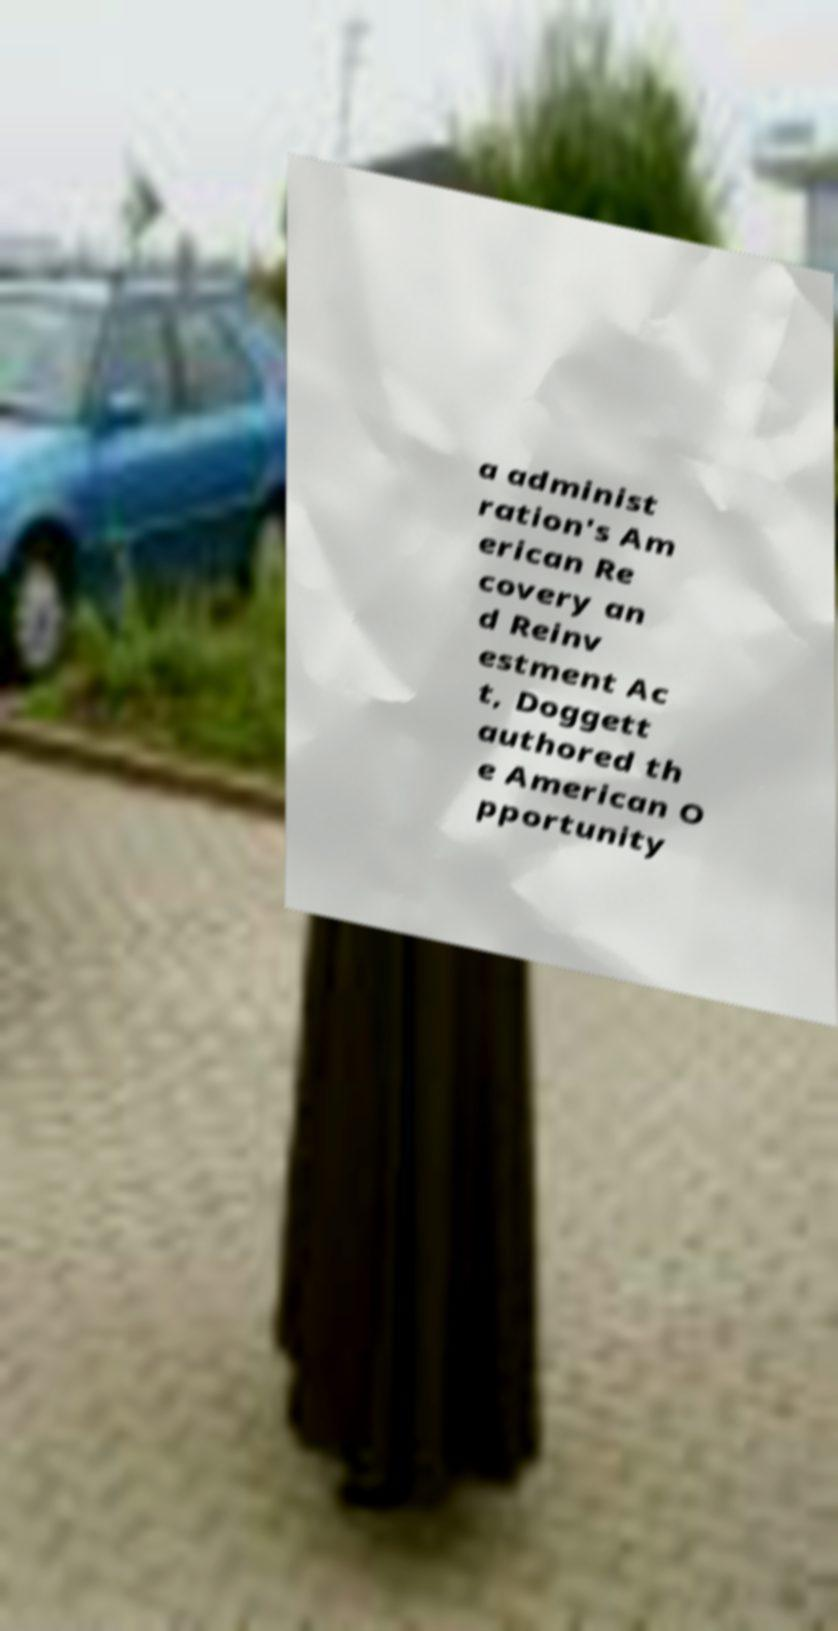Can you read and provide the text displayed in the image?This photo seems to have some interesting text. Can you extract and type it out for me? a administ ration's Am erican Re covery an d Reinv estment Ac t, Doggett authored th e American O pportunity 